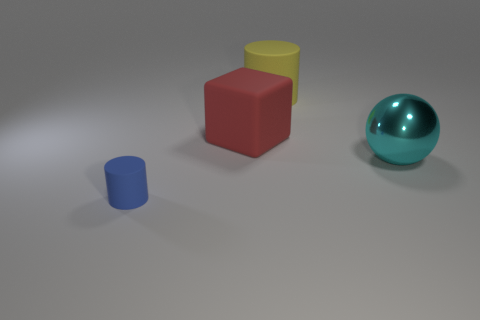Are there the same number of large metallic balls behind the big yellow thing and big things that are in front of the blue rubber cylinder?
Your response must be concise. Yes. Is there any other thing that has the same material as the tiny blue cylinder?
Provide a short and direct response. Yes. Is the size of the yellow matte cylinder the same as the rubber cylinder that is in front of the large cyan object?
Ensure brevity in your answer.  No. The cylinder that is behind the cylinder on the left side of the large yellow thing is made of what material?
Your response must be concise. Rubber. Is the number of large cyan metal things that are left of the tiny blue thing the same as the number of big cylinders?
Provide a short and direct response. No. What is the size of the object that is left of the cyan ball and in front of the red thing?
Offer a terse response. Small. The cylinder behind the rubber thing that is to the left of the block is what color?
Give a very brief answer. Yellow. How many green objects are large metal balls or large cylinders?
Your answer should be very brief. 0. The object that is both on the left side of the yellow rubber object and right of the blue cylinder is what color?
Provide a short and direct response. Red. What number of small things are either cyan balls or red rubber things?
Offer a very short reply. 0. 